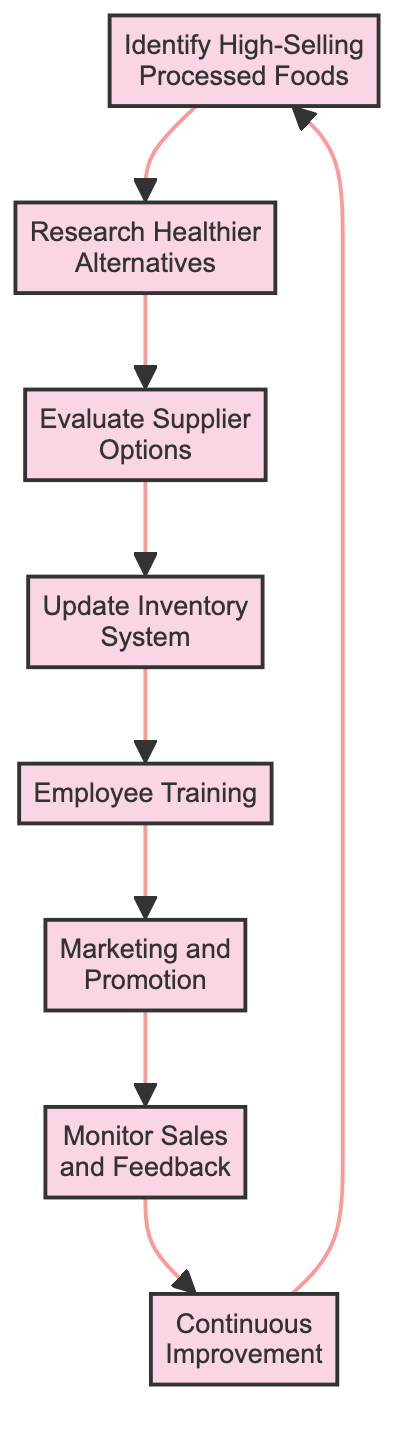What is the first step in the inventory adjustment process? The first step in the diagram is labeled "Identify High-Selling Processed Foods," indicating that the process starts with analyzing sales data to find top-selling items.
Answer: Identify High-Selling Processed Foods How many steps are there in the process? Counting the nodes in the diagram, there are a total of eight distinct steps, from identifying high-selling processed foods to continuous improvement.
Answer: Eight What follows "Employee Training" in the flow? The flow chart shows that after "Employee Training," the next step is "Marketing and Promotion," which follows directly.
Answer: Marketing and Promotion What is the last process in the diagram? The last process before returning to the start is "Continuous Improvement," which indicates ongoing evaluation of the impact of the changes made.
Answer: Continuous Improvement Which process involves gathering customer feedback? The process titled "Monitor Sales and Feedback" is specifically where tracking sales of the new options and gathering customer feedback occurs.
Answer: Monitor Sales and Feedback What is the relationship between "Evaluate Supplier Options" and "Update Inventory System"? The diagram indicates that "Evaluate Supplier Options" directly leads to "Update Inventory System," showing that supplier evaluations precede inventory updates.
Answer: Directly leads to What type of alternatives is researched after identifying high-selling processed foods? The process that follows is to "Research Healthier Alternatives," emphasizing the aim to find healthier options to replace the processed foods identified.
Answer: Healthier Alternatives How is marketing for the new products initiated? After "Employee Training," the process of "Marketing and Promotion" is launched, indicating the start of marketing efforts for the new product options.
Answer: Marketing and Promotion What action is taken after monitoring sales and feedback? The subsequent action is "Continuous Improvement," which means that adjustments and evaluations take place following the monitoring phase.
Answer: Continuous Improvement 